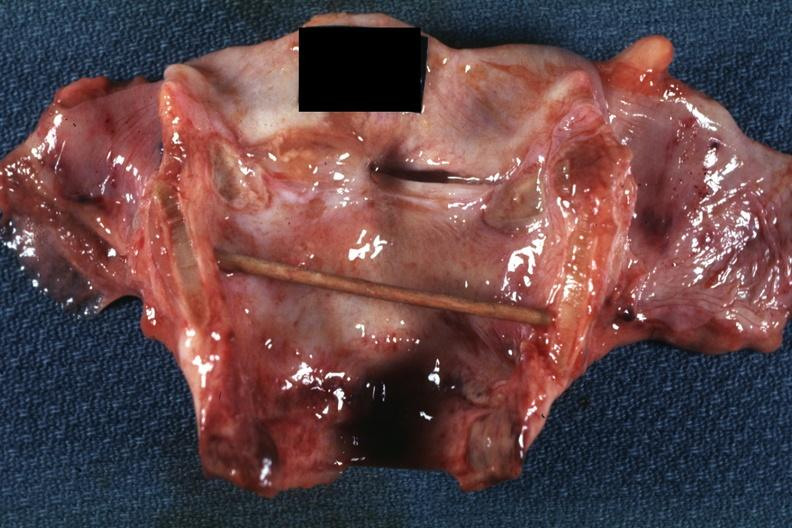what is present?
Answer the question using a single word or phrase. Ulcer 